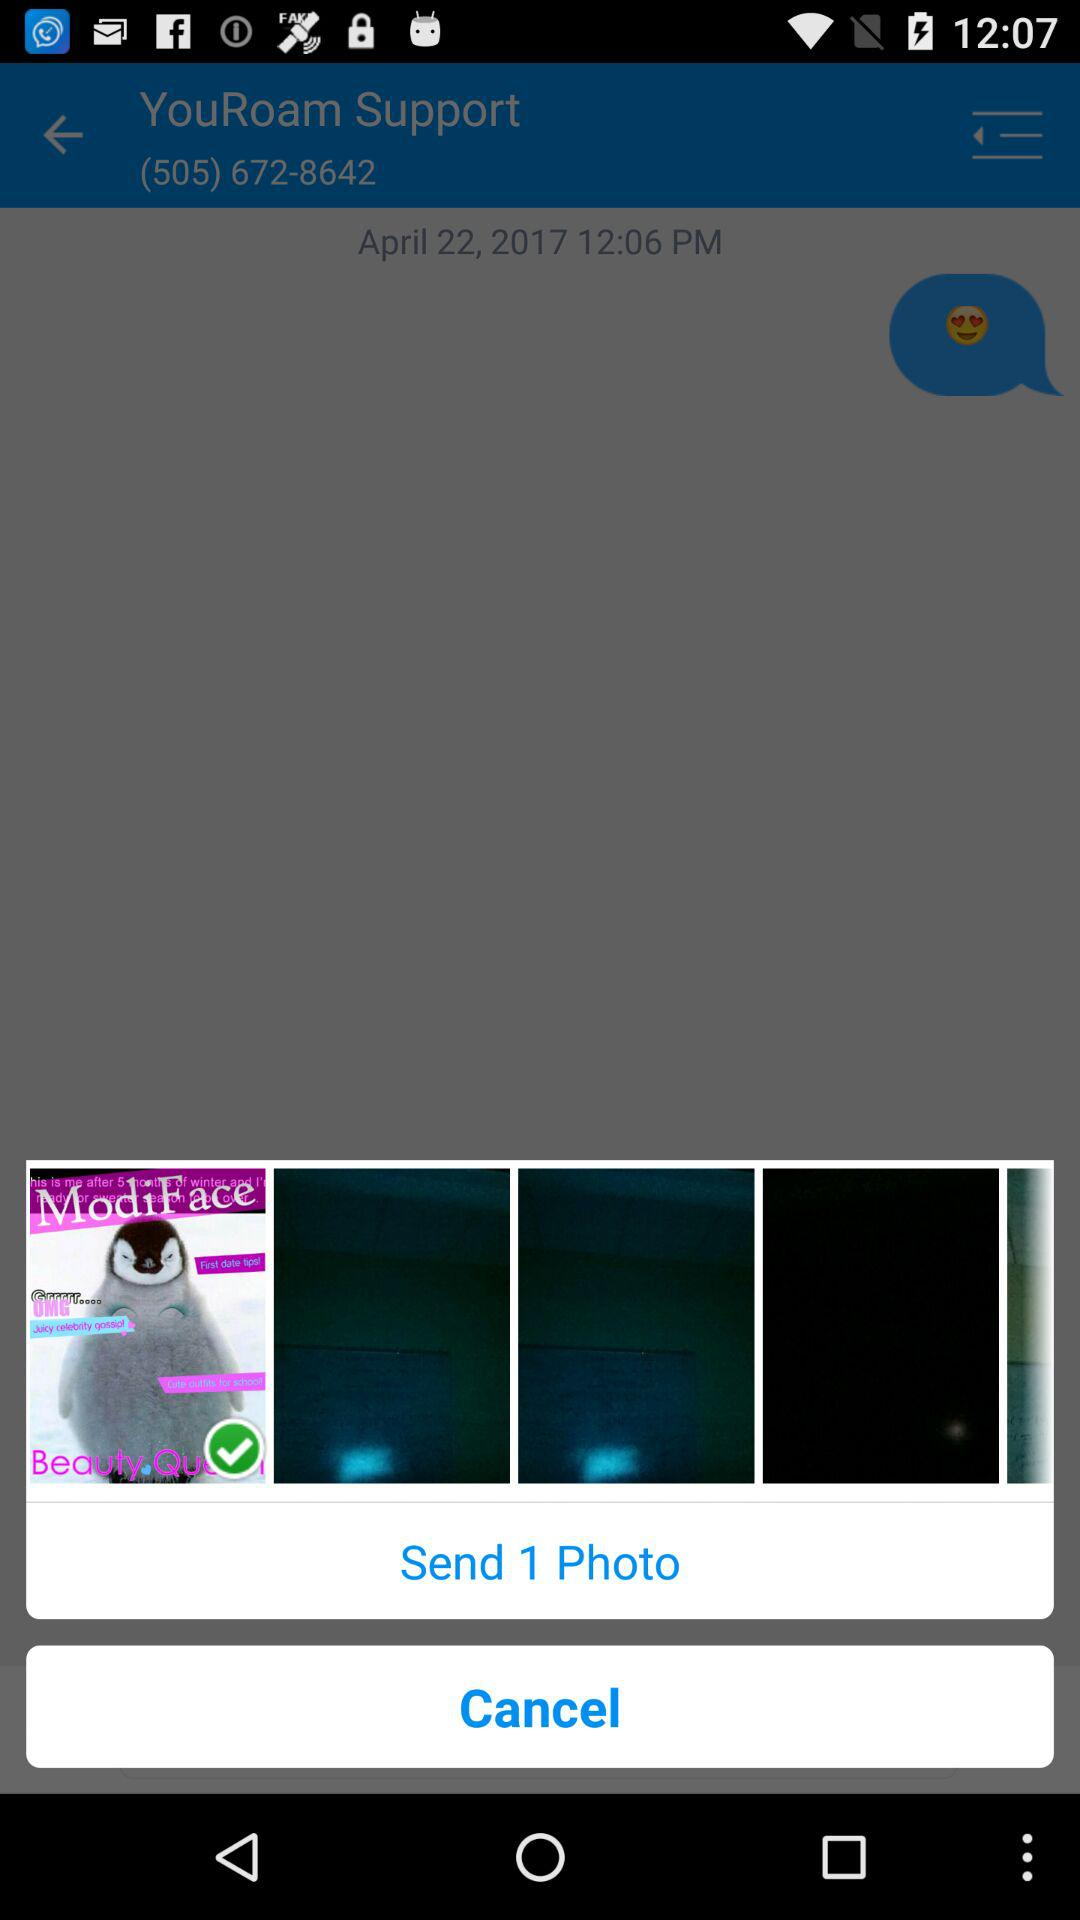To whom is the photo sent?
When the provided information is insufficient, respond with <no answer>. <no answer> 